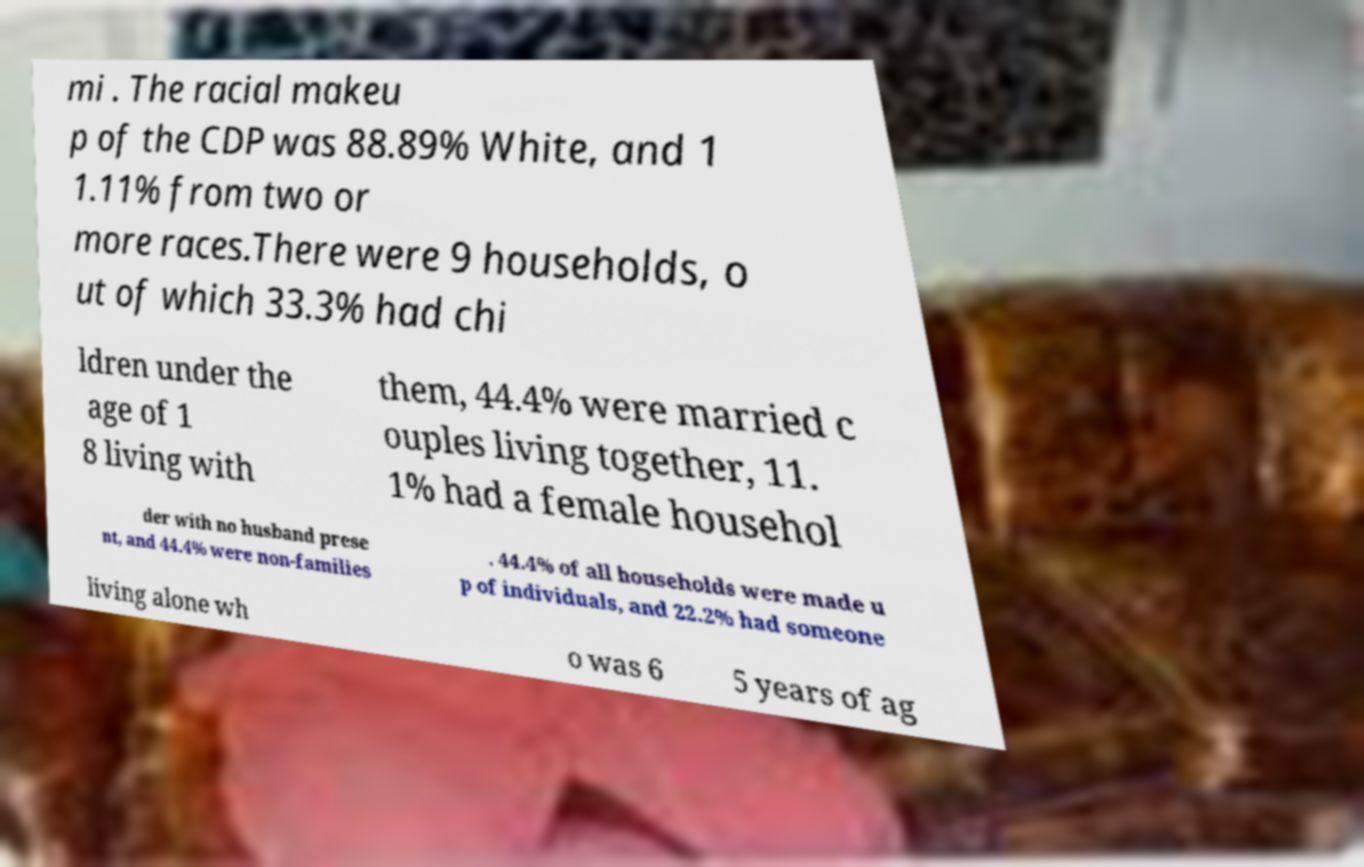Can you accurately transcribe the text from the provided image for me? mi . The racial makeu p of the CDP was 88.89% White, and 1 1.11% from two or more races.There were 9 households, o ut of which 33.3% had chi ldren under the age of 1 8 living with them, 44.4% were married c ouples living together, 11. 1% had a female househol der with no husband prese nt, and 44.4% were non-families . 44.4% of all households were made u p of individuals, and 22.2% had someone living alone wh o was 6 5 years of ag 